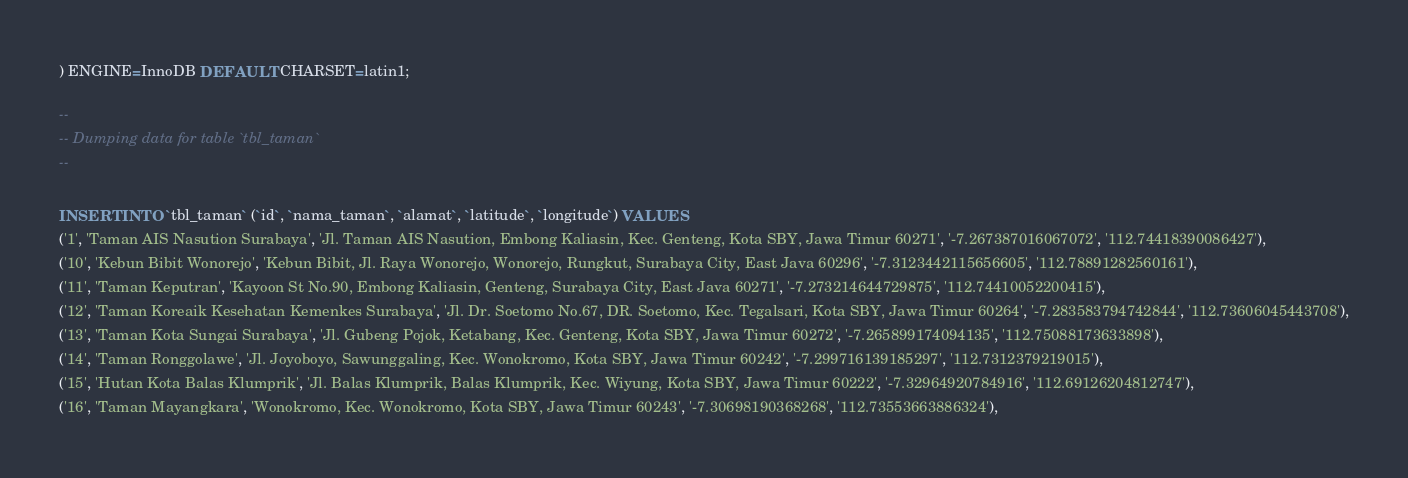Convert code to text. <code><loc_0><loc_0><loc_500><loc_500><_SQL_>) ENGINE=InnoDB DEFAULT CHARSET=latin1;

--
-- Dumping data for table `tbl_taman`
--

INSERT INTO `tbl_taman` (`id`, `nama_taman`, `alamat`, `latitude`, `longitude`) VALUES
('1', 'Taman AIS Nasution Surabaya', 'Jl. Taman AIS Nasution, Embong Kaliasin, Kec. Genteng, Kota SBY, Jawa Timur 60271', '-7.267387016067072', '112.74418390086427'),
('10', 'Kebun Bibit Wonorejo', 'Kebun Bibit, Jl. Raya Wonorejo, Wonorejo, Rungkut, Surabaya City, East Java 60296', '-7.3123442115656605', '112.78891282560161'),
('11', 'Taman Keputran', 'Kayoon St No.90, Embong Kaliasin, Genteng, Surabaya City, East Java 60271', '-7.273214644729875', '112.74410052200415'),
('12', 'Taman Koreaik Kesehatan Kemenkes Surabaya', 'Jl. Dr. Soetomo No.67, DR. Soetomo, Kec. Tegalsari, Kota SBY, Jawa Timur 60264', '-7.283583794742844', '112.73606045443708'),
('13', 'Taman Kota Sungai Surabaya', 'Jl. Gubeng Pojok, Ketabang, Kec. Genteng, Kota SBY, Jawa Timur 60272', '-7.265899174094135', '112.75088173633898'),
('14', 'Taman Ronggolawe', 'Jl. Joyoboyo, Sawunggaling, Kec. Wonokromo, Kota SBY, Jawa Timur 60242', '-7.299716139185297', '112.7312379219015'),
('15', 'Hutan Kota Balas Klumprik', 'Jl. Balas Klumprik, Balas Klumprik, Kec. Wiyung, Kota SBY, Jawa Timur 60222', '-7.32964920784916', '112.69126204812747'),
('16', 'Taman Mayangkara', 'Wonokromo, Kec. Wonokromo, Kota SBY, Jawa Timur 60243', '-7.30698190368268', '112.73553663886324'),</code> 